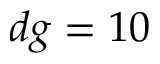<formula> <loc_0><loc_0><loc_500><loc_500>d g = 1 0</formula> 